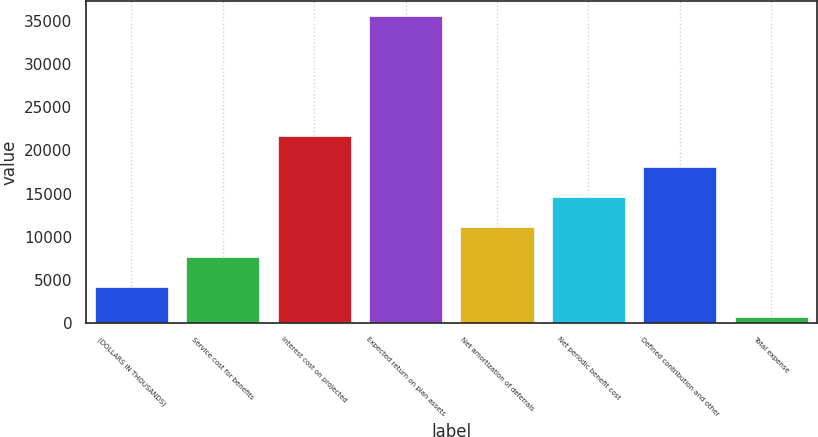Convert chart. <chart><loc_0><loc_0><loc_500><loc_500><bar_chart><fcel>(DOLLARS IN THOUSANDS)<fcel>Service cost for benefits<fcel>Interest cost on projected<fcel>Expected return on plan assets<fcel>Net amortization of deferrals<fcel>Net periodic benefit cost<fcel>Defined contribution and other<fcel>Total expense<nl><fcel>4188.6<fcel>7676.2<fcel>21626.6<fcel>35577<fcel>11163.8<fcel>14651.4<fcel>18139<fcel>701<nl></chart> 